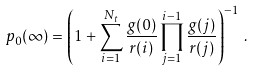Convert formula to latex. <formula><loc_0><loc_0><loc_500><loc_500>p _ { 0 } ( \infty ) = \left ( 1 + \sum _ { i = 1 } ^ { N _ { t } } \frac { g ( 0 ) } { r ( i ) } \prod _ { j = 1 } ^ { i - 1 } \frac { g ( j ) } { r ( j ) } \right ) ^ { - 1 } \, .</formula> 